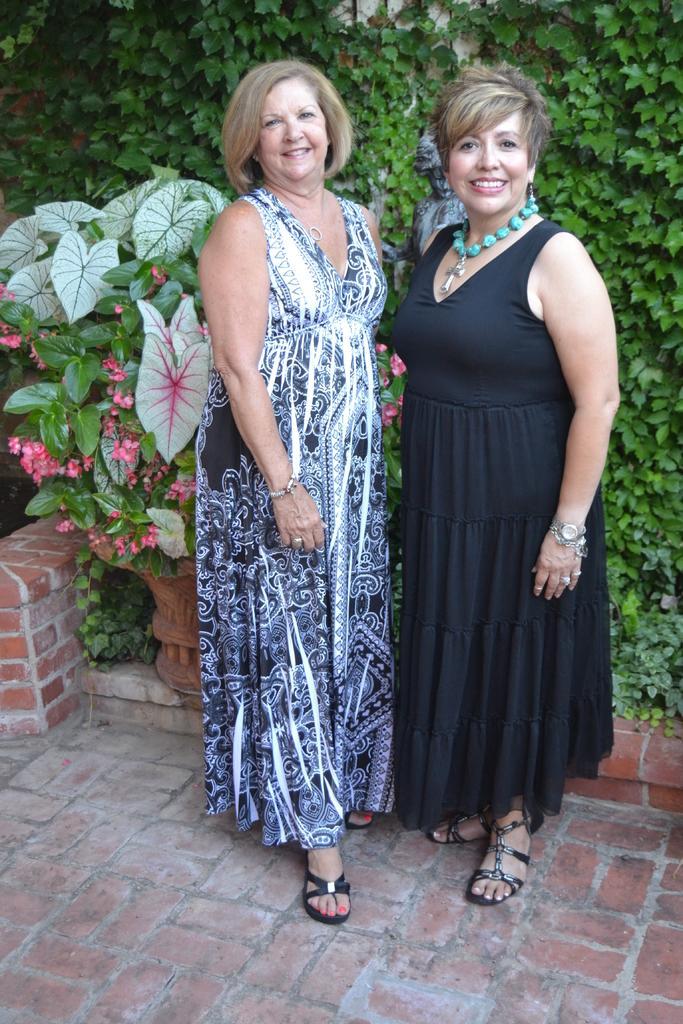Describe this image in one or two sentences. In this picture I can see two persons standing and smiling, and in the background there are plants and flowers. 